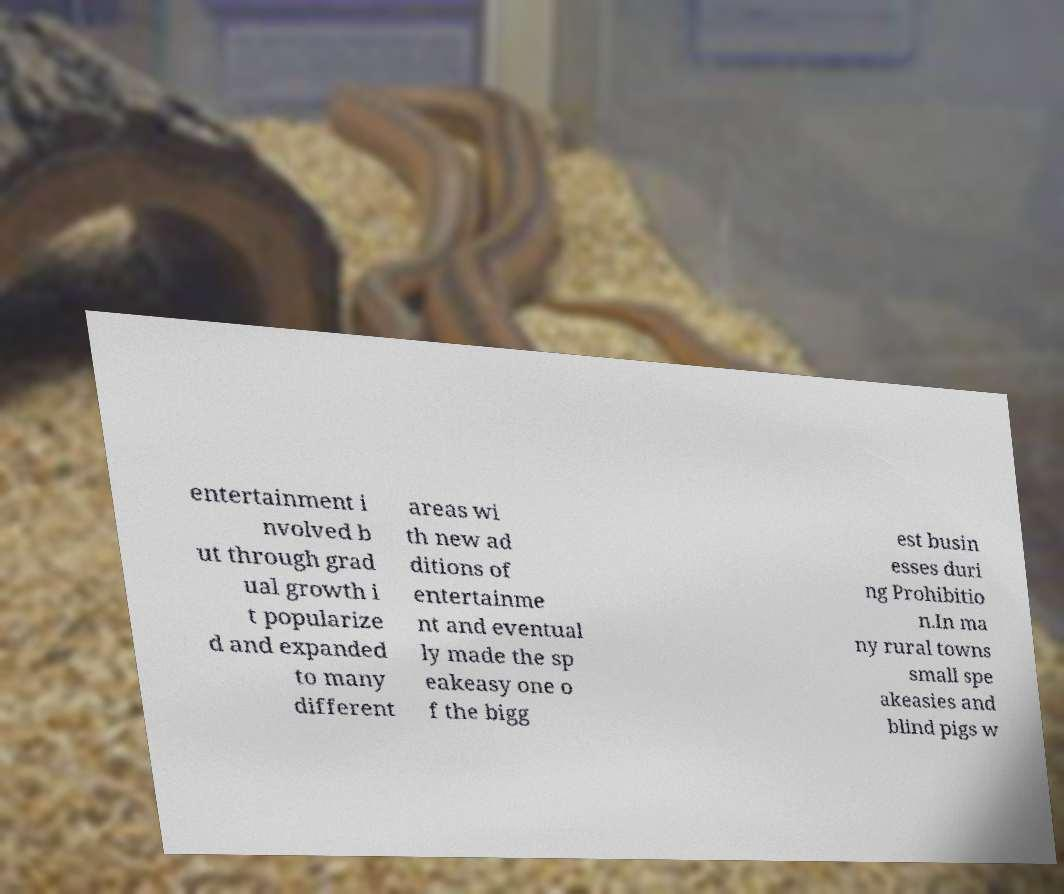For documentation purposes, I need the text within this image transcribed. Could you provide that? entertainment i nvolved b ut through grad ual growth i t popularize d and expanded to many different areas wi th new ad ditions of entertainme nt and eventual ly made the sp eakeasy one o f the bigg est busin esses duri ng Prohibitio n.In ma ny rural towns small spe akeasies and blind pigs w 